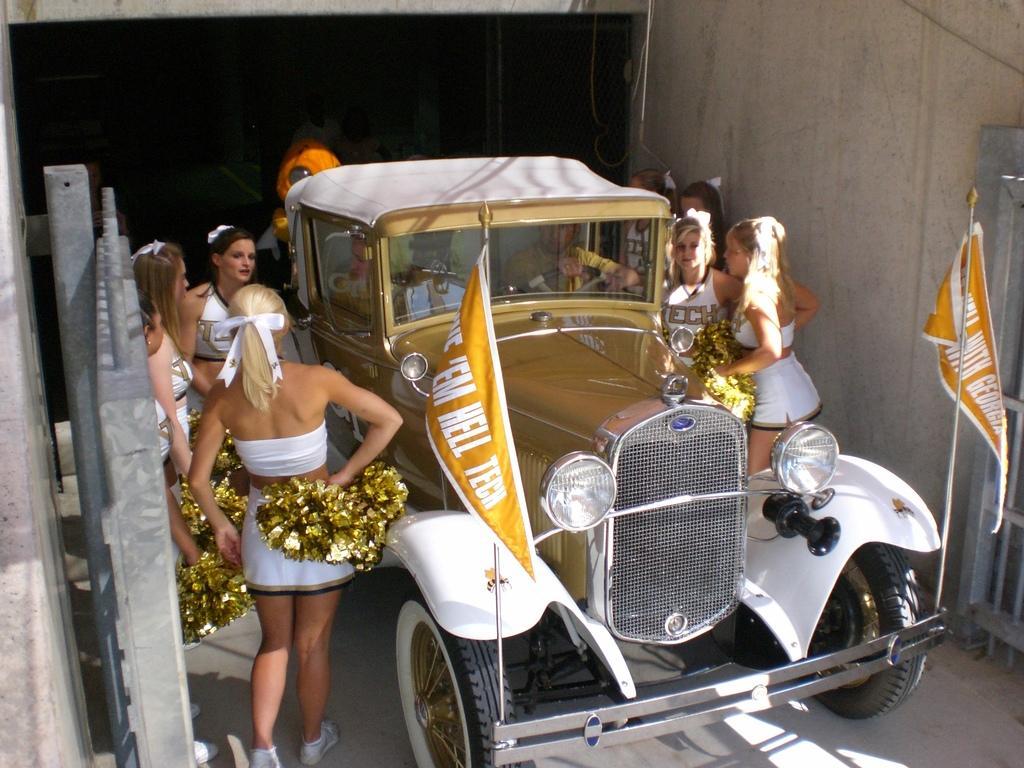Could you give a brief overview of what you see in this image? In this Image, we can see a car and there are some girls standing around the car, we can see an iron gate. 